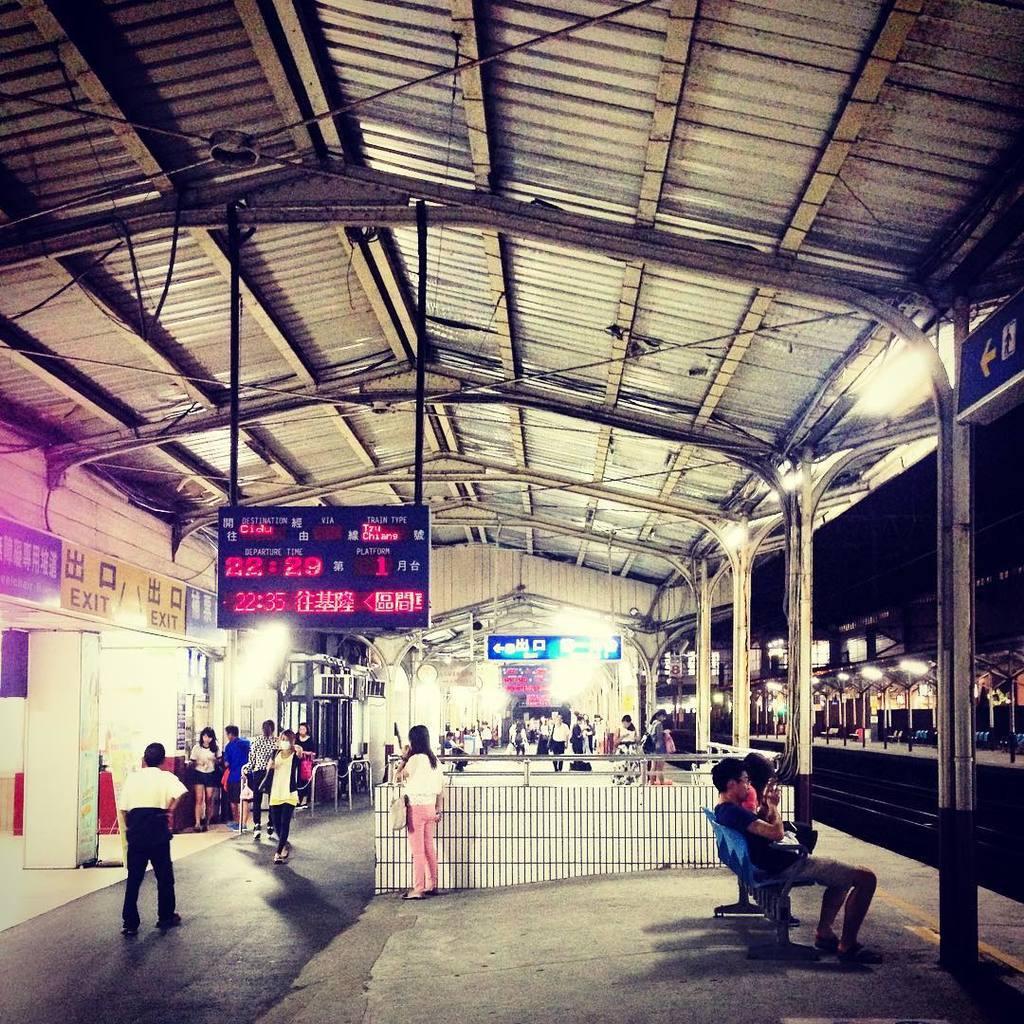In one or two sentences, can you explain what this image depicts? This image might be taken in an railway station. In this image we can see persons, display board, platforms, pillars, lights, sign boards, wires, air conditioners, check gates and chairs. 